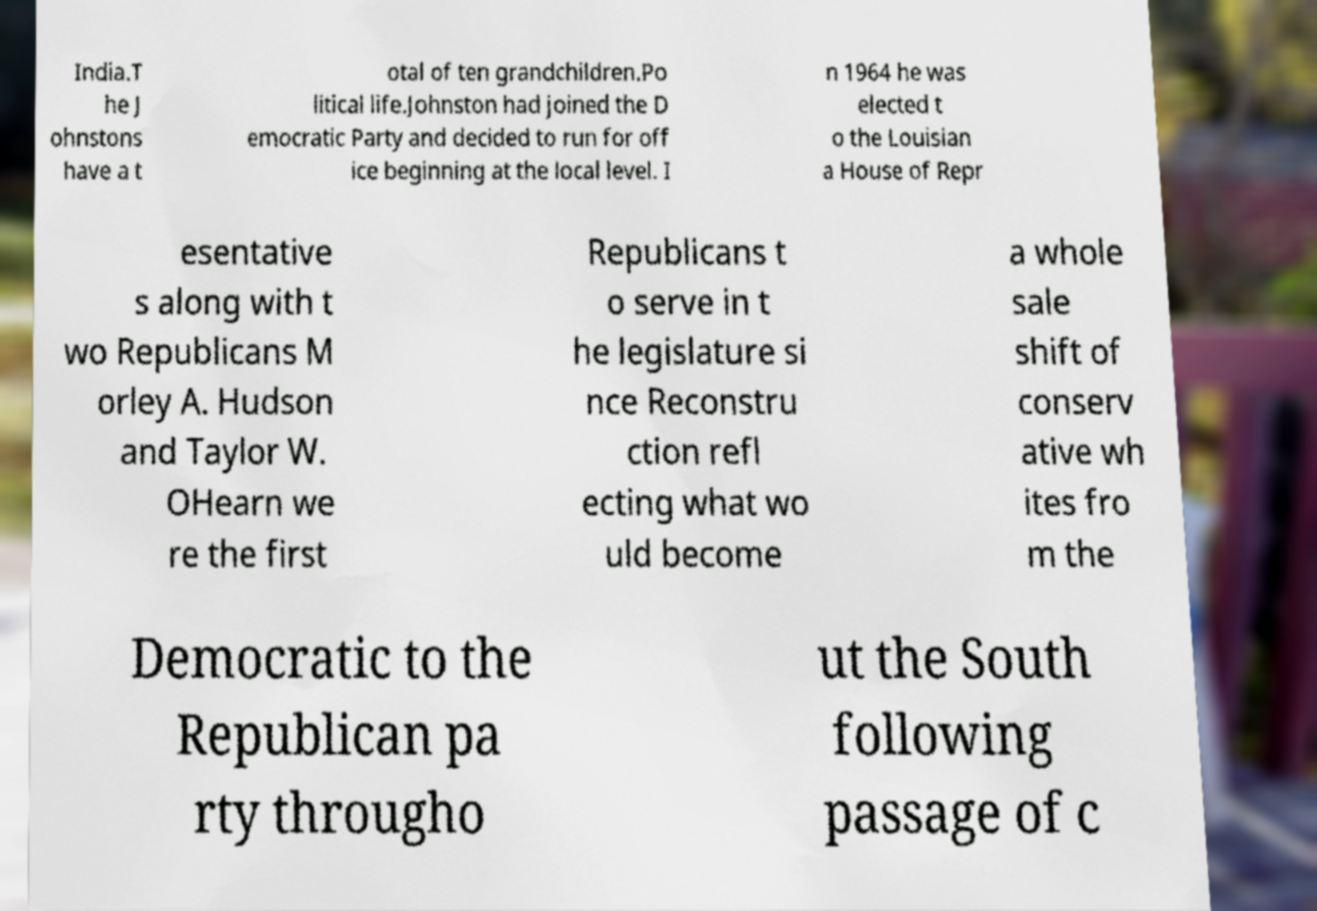Please read and relay the text visible in this image. What does it say? India.T he J ohnstons have a t otal of ten grandchildren.Po litical life.Johnston had joined the D emocratic Party and decided to run for off ice beginning at the local level. I n 1964 he was elected t o the Louisian a House of Repr esentative s along with t wo Republicans M orley A. Hudson and Taylor W. OHearn we re the first Republicans t o serve in t he legislature si nce Reconstru ction refl ecting what wo uld become a whole sale shift of conserv ative wh ites fro m the Democratic to the Republican pa rty througho ut the South following passage of c 